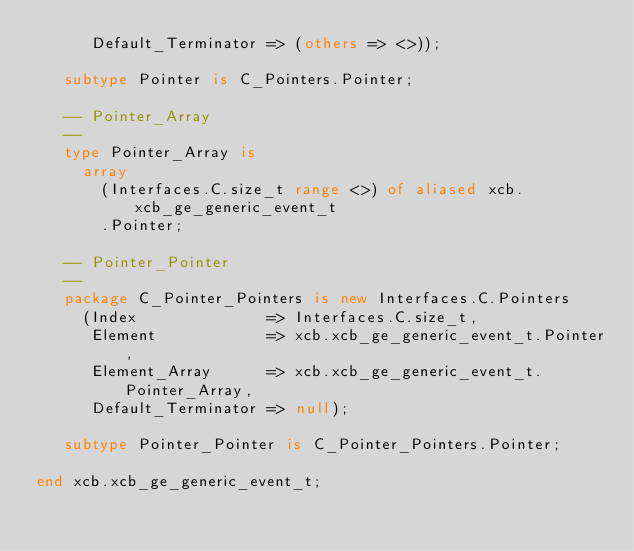Convert code to text. <code><loc_0><loc_0><loc_500><loc_500><_Ada_>      Default_Terminator => (others => <>));

   subtype Pointer is C_Pointers.Pointer;

   -- Pointer_Array
   --
   type Pointer_Array is
     array
       (Interfaces.C.size_t range <>) of aliased xcb.xcb_ge_generic_event_t
       .Pointer;

   -- Pointer_Pointer
   --
   package C_Pointer_Pointers is new Interfaces.C.Pointers
     (Index              => Interfaces.C.size_t,
      Element            => xcb.xcb_ge_generic_event_t.Pointer,
      Element_Array      => xcb.xcb_ge_generic_event_t.Pointer_Array,
      Default_Terminator => null);

   subtype Pointer_Pointer is C_Pointer_Pointers.Pointer;

end xcb.xcb_ge_generic_event_t;
</code> 